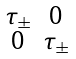Convert formula to latex. <formula><loc_0><loc_0><loc_500><loc_500>\begin{smallmatrix} \tau _ { \pm } & 0 \\ 0 & \tau _ { \pm } \end{smallmatrix}</formula> 